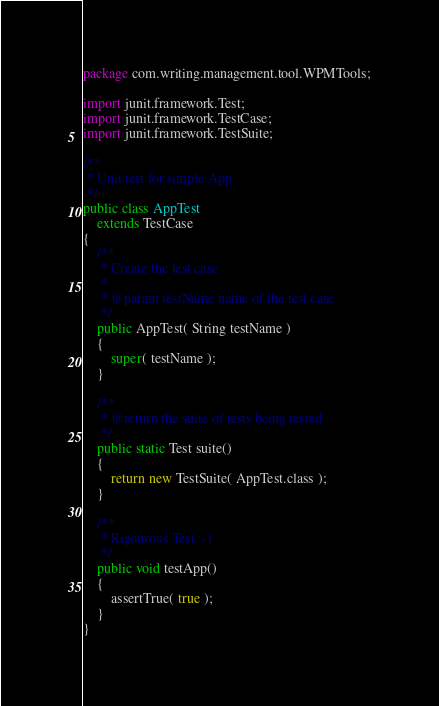<code> <loc_0><loc_0><loc_500><loc_500><_Java_>package com.writing.management.tool.WPMTools;

import junit.framework.Test;
import junit.framework.TestCase;
import junit.framework.TestSuite;

/**
 * Unit test for simple App.
 */
public class AppTest 
    extends TestCase
{
    /**
     * Create the test case
     *
     * @param testName name of the test case
     */
    public AppTest( String testName )
    {
        super( testName );
    }

    /**
     * @return the suite of tests being tested
     */
    public static Test suite()
    {
        return new TestSuite( AppTest.class );
    }

    /**
     * Rigourous Test :-)
     */
    public void testApp()
    {
        assertTrue( true );
    }
}
</code> 